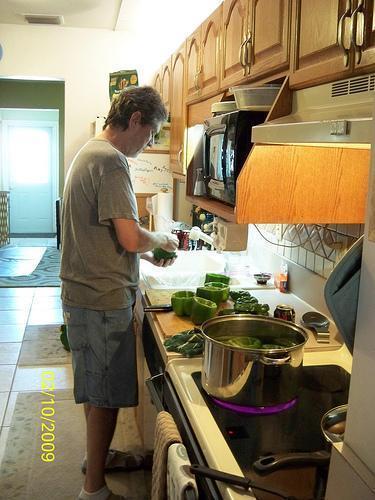How many people are in the photo?
Give a very brief answer. 1. 